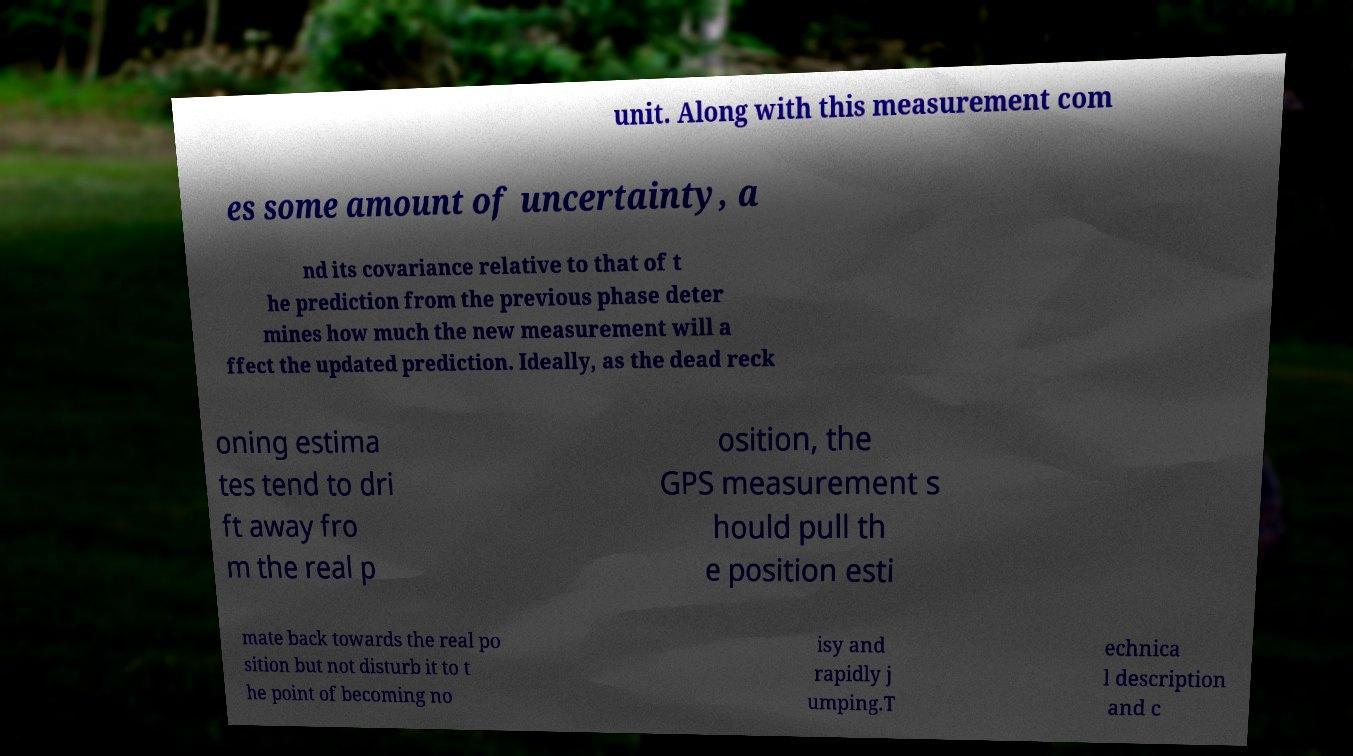Could you extract and type out the text from this image? unit. Along with this measurement com es some amount of uncertainty, a nd its covariance relative to that of t he prediction from the previous phase deter mines how much the new measurement will a ffect the updated prediction. Ideally, as the dead reck oning estima tes tend to dri ft away fro m the real p osition, the GPS measurement s hould pull th e position esti mate back towards the real po sition but not disturb it to t he point of becoming no isy and rapidly j umping.T echnica l description and c 